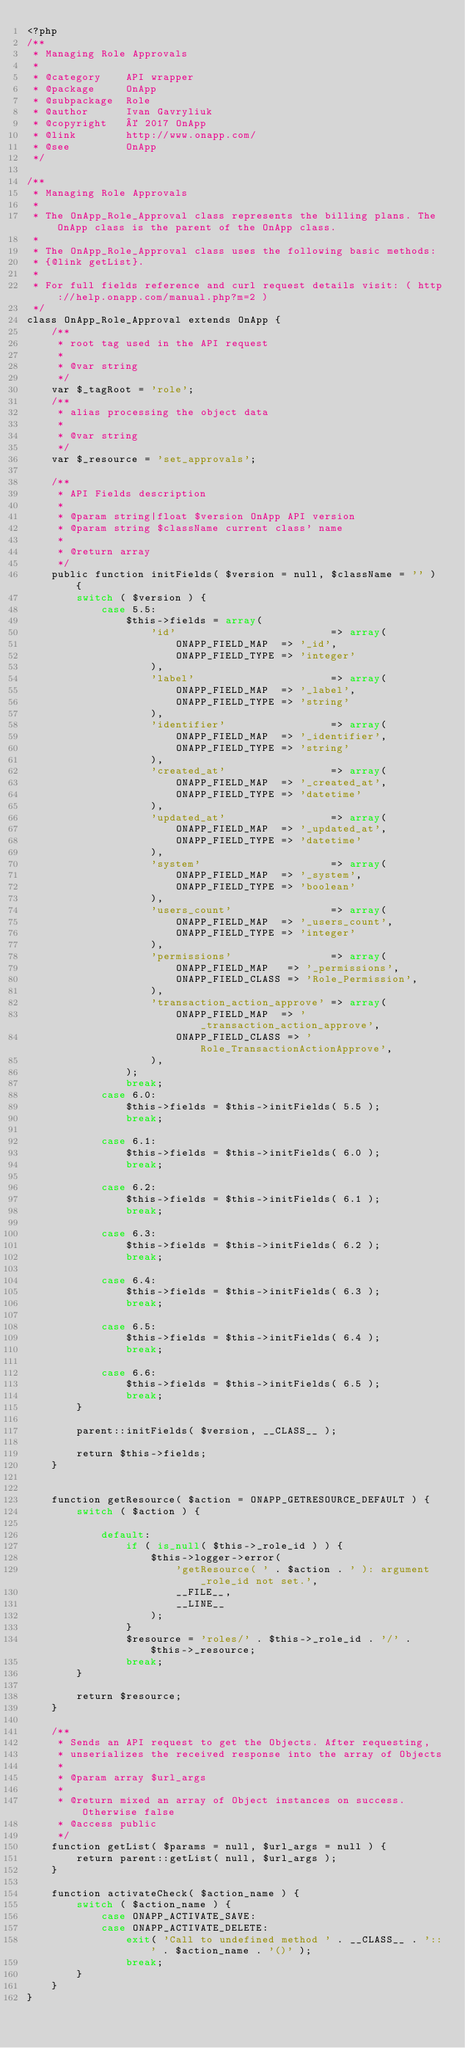<code> <loc_0><loc_0><loc_500><loc_500><_PHP_><?php
/**
 * Managing Role Approvals
 *
 * @category    API wrapper
 * @package     OnApp
 * @subpackage  Role
 * @author      Ivan Gavryliuk
 * @copyright   © 2017 OnApp
 * @link        http://www.onapp.com/
 * @see         OnApp
 */

/**
 * Managing Role Approvals
 *
 * The OnApp_Role_Approval class represents the billing plans. The OnApp class is the parent of the OnApp class.
 *
 * The OnApp_Role_Approval class uses the following basic methods:
 * {@link getList}.
 *
 * For full fields reference and curl request details visit: ( http://help.onapp.com/manual.php?m=2 )
 */
class OnApp_Role_Approval extends OnApp {
    /**
     * root tag used in the API request
     *
     * @var string
     */
    var $_tagRoot = 'role';
    /**
     * alias processing the object data
     *
     * @var string
     */
    var $_resource = 'set_approvals';

    /**
     * API Fields description
     *
     * @param string|float $version OnApp API version
     * @param string $className current class' name
     *
     * @return array
     */
    public function initFields( $version = null, $className = '' ) {
        switch ( $version ) {
            case 5.5:
                $this->fields = array(
                    'id'                         => array(
                        ONAPP_FIELD_MAP  => '_id',
                        ONAPP_FIELD_TYPE => 'integer'
                    ),
                    'label'                      => array(
                        ONAPP_FIELD_MAP  => '_label',
                        ONAPP_FIELD_TYPE => 'string'
                    ),
                    'identifier'                 => array(
                        ONAPP_FIELD_MAP  => '_identifier',
                        ONAPP_FIELD_TYPE => 'string'
                    ),
                    'created_at'                 => array(
                        ONAPP_FIELD_MAP  => '_created_at',
                        ONAPP_FIELD_TYPE => 'datetime'
                    ),
                    'updated_at'                 => array(
                        ONAPP_FIELD_MAP  => '_updated_at',
                        ONAPP_FIELD_TYPE => 'datetime'
                    ),
                    'system'                     => array(
                        ONAPP_FIELD_MAP  => '_system',
                        ONAPP_FIELD_TYPE => 'boolean'
                    ),
                    'users_count'                => array(
                        ONAPP_FIELD_MAP  => '_users_count',
                        ONAPP_FIELD_TYPE => 'integer'
                    ),
                    'permissions'                => array(
                        ONAPP_FIELD_MAP   => '_permissions',
                        ONAPP_FIELD_CLASS => 'Role_Permission',
                    ),
                    'transaction_action_approve' => array(
                        ONAPP_FIELD_MAP  => '_transaction_action_approve',
                        ONAPP_FIELD_CLASS => 'Role_TransactionActionApprove',
                    ),
                );
                break;
            case 6.0:
                $this->fields = $this->initFields( 5.5 );
                break;

            case 6.1:
                $this->fields = $this->initFields( 6.0 );
                break;

            case 6.2:
                $this->fields = $this->initFields( 6.1 );
                break;

            case 6.3:
                $this->fields = $this->initFields( 6.2 );
                break;

            case 6.4:
                $this->fields = $this->initFields( 6.3 );
                break;

            case 6.5:
                $this->fields = $this->initFields( 6.4 );
                break;

            case 6.6:
                $this->fields = $this->initFields( 6.5 );
                break;
        }

        parent::initFields( $version, __CLASS__ );

        return $this->fields;
    }


    function getResource( $action = ONAPP_GETRESOURCE_DEFAULT ) {
        switch ( $action ) {

            default:
                if ( is_null( $this->_role_id ) ) {
                    $this->logger->error(
                        'getResource( ' . $action . ' ): argument _role_id not set.',
                        __FILE__,
                        __LINE__
                    );
                }
                $resource = 'roles/' . $this->_role_id . '/' . $this->_resource;
                break;
        }

        return $resource;
    }

    /**
     * Sends an API request to get the Objects. After requesting,
     * unserializes the received response into the array of Objects
     *
     * @param array $url_args
     *
     * @return mixed an array of Object instances on success. Otherwise false
     * @access public
     */
    function getList( $params = null, $url_args = null ) {
        return parent::getList( null, $url_args );
    }

    function activateCheck( $action_name ) {
        switch ( $action_name ) {
            case ONAPP_ACTIVATE_SAVE:
            case ONAPP_ACTIVATE_DELETE:
                exit( 'Call to undefined method ' . __CLASS__ . '::' . $action_name . '()' );
                break;
        }
    }
}</code> 